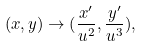<formula> <loc_0><loc_0><loc_500><loc_500>( x , y ) \rightarrow ( \frac { x ^ { \prime } } { u ^ { 2 } } , \frac { y ^ { \prime } } { u ^ { 3 } } ) ,</formula> 